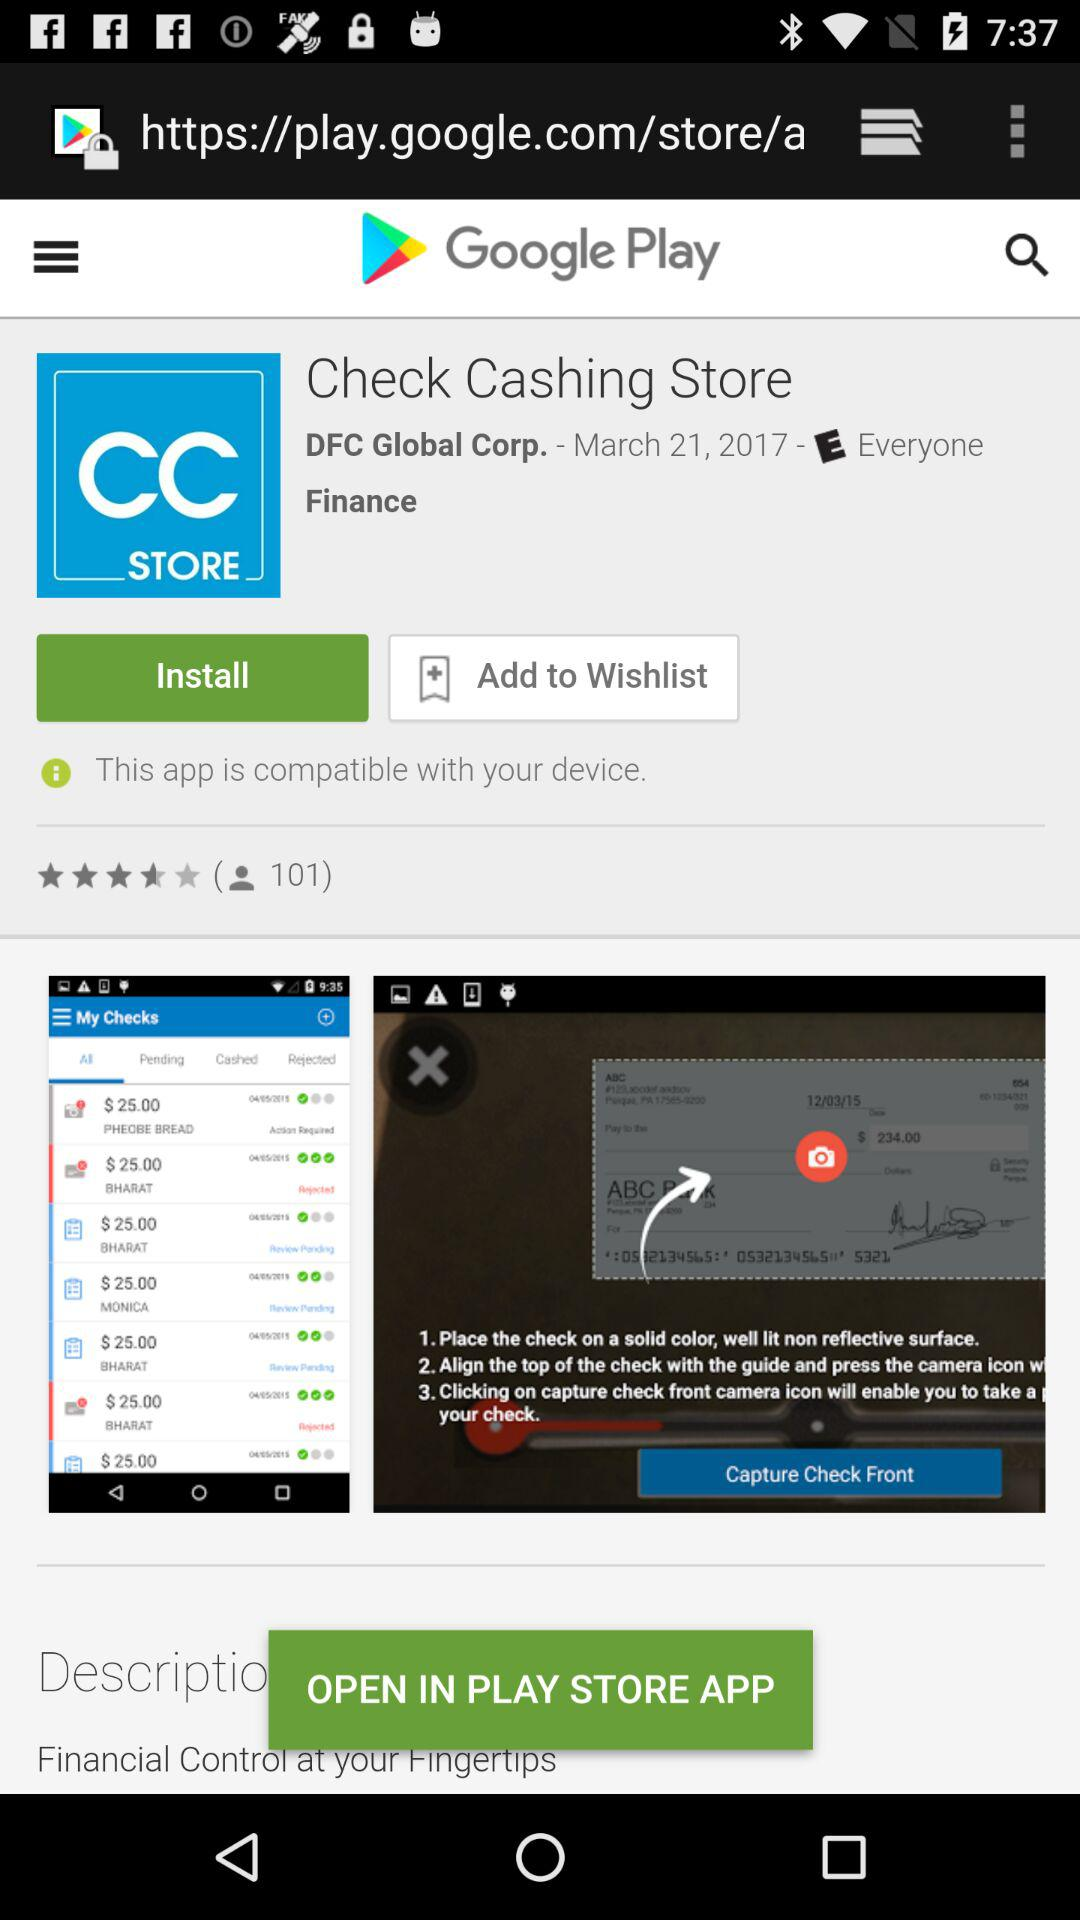What application is open in the Google Play store? The application is "Check Cashing Store". 